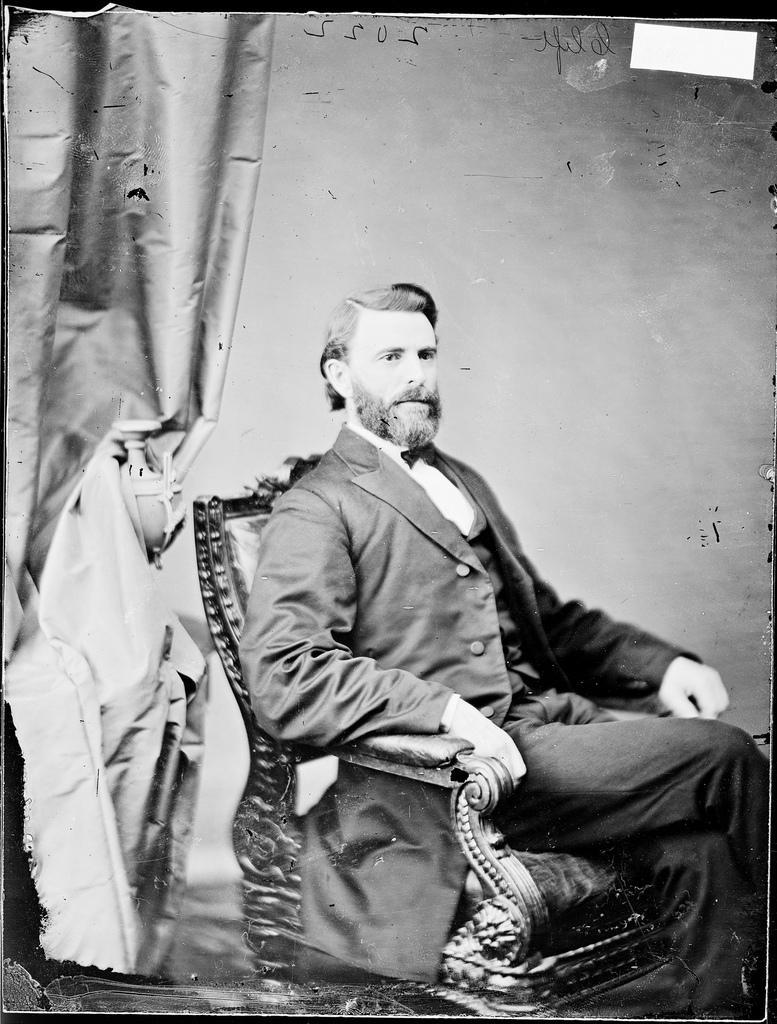In one or two sentences, can you explain what this image depicts? This image consists of a man sitting in a chair. He is wearing a suit in black color. In the background, there is a wall. On the left, there is a curtain. 